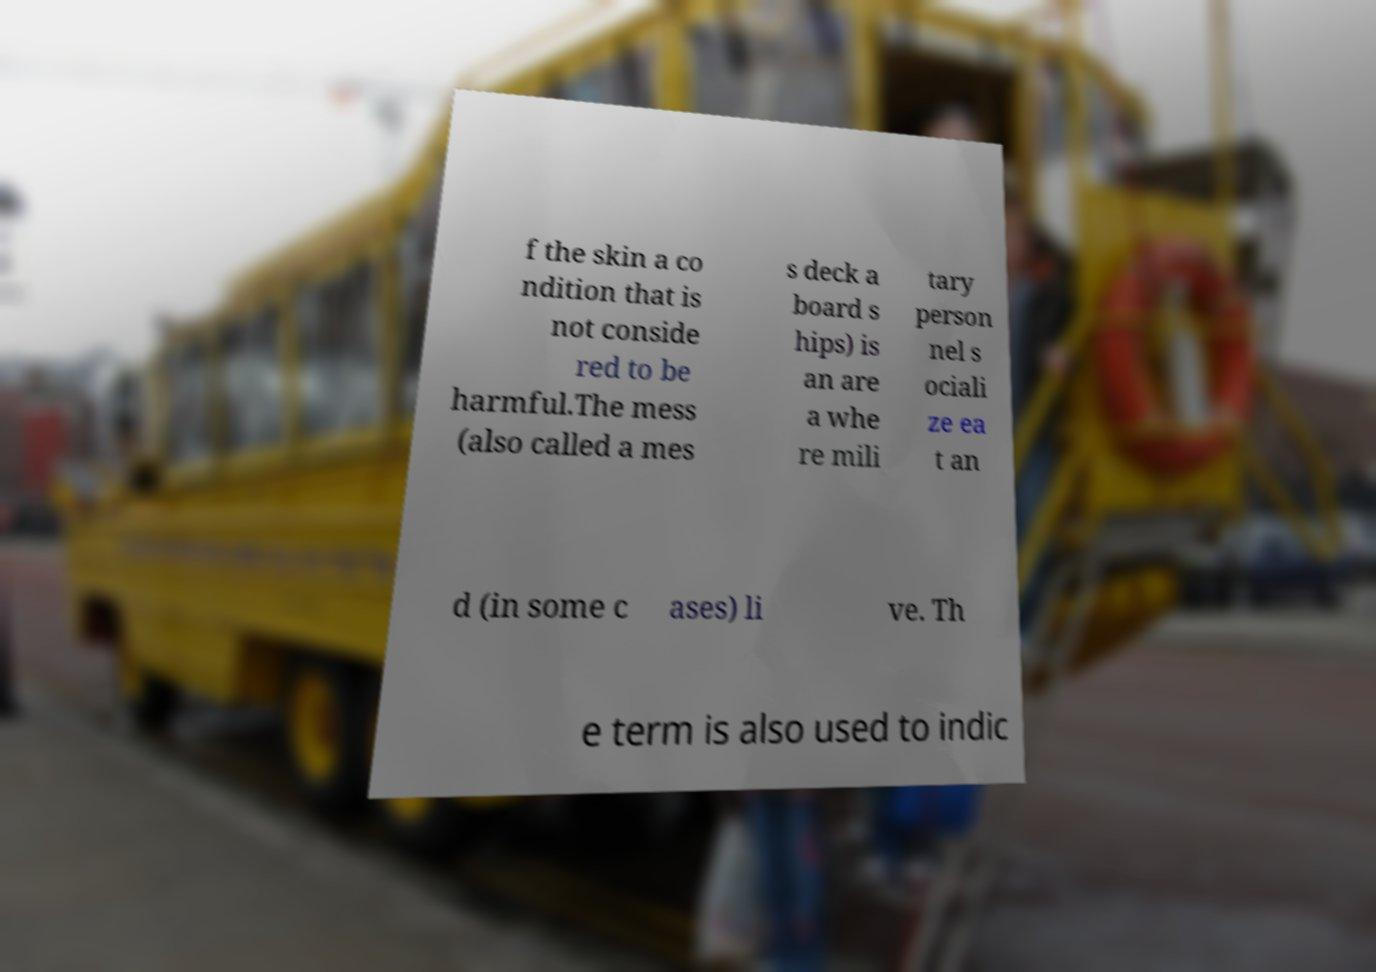Can you accurately transcribe the text from the provided image for me? f the skin a co ndition that is not conside red to be harmful.The mess (also called a mes s deck a board s hips) is an are a whe re mili tary person nel s ociali ze ea t an d (in some c ases) li ve. Th e term is also used to indic 